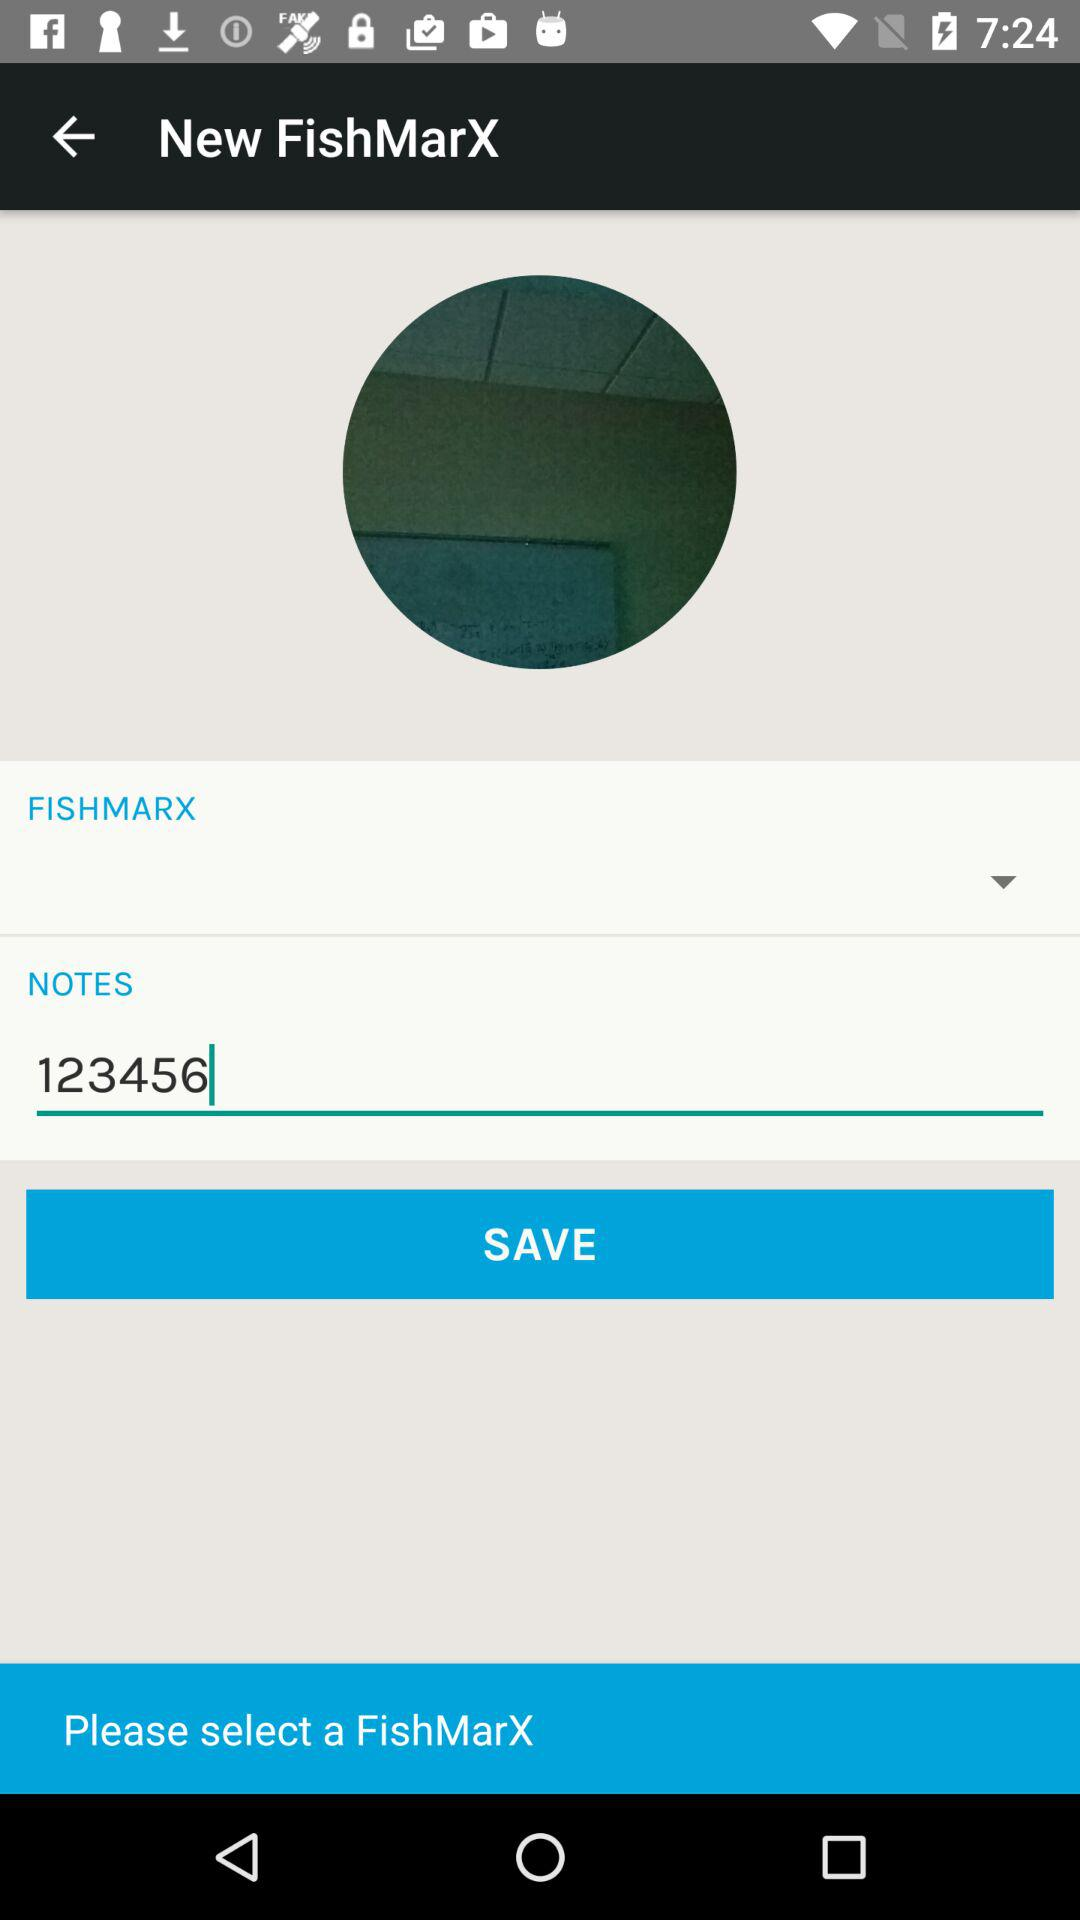What is written in the notes? The written note is 123456. 